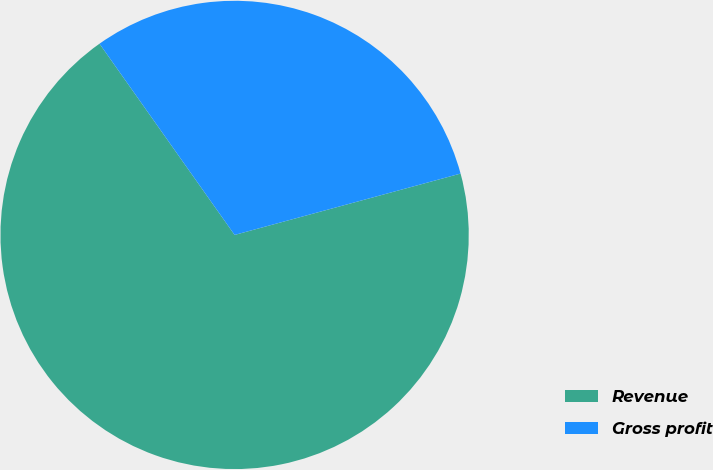Convert chart to OTSL. <chart><loc_0><loc_0><loc_500><loc_500><pie_chart><fcel>Revenue<fcel>Gross profit<nl><fcel>69.43%<fcel>30.57%<nl></chart> 